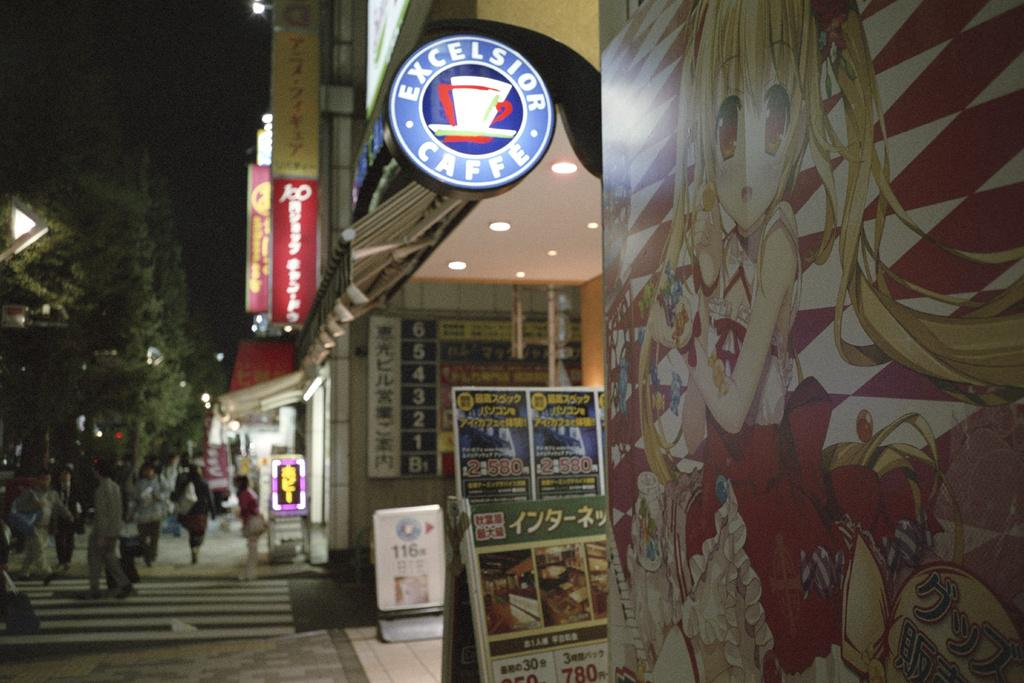<image>
Offer a succinct explanation of the picture presented. A round coffee shop sign is lit to reveal the name Excelsior Caffe. 